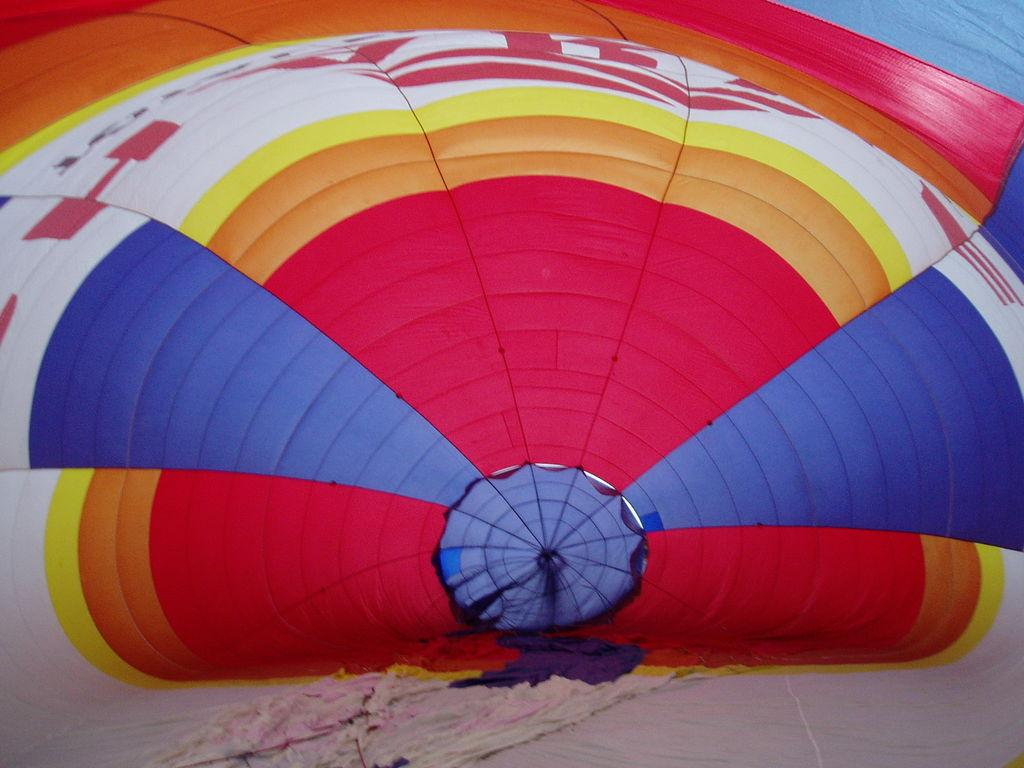What is the main subject of the image? The main subject of the image is a colorful air balloon. What type of wood can be seen supporting the robin in the image? There is no robin or wood present in the image; it features a colorful air balloon. What type of volleyball can be seen being played in the image? There is no volleyball or indication of a game being played in the image; it features a colorful air balloon. 